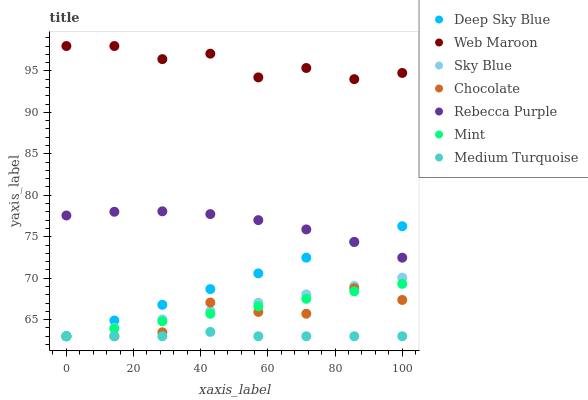Does Medium Turquoise have the minimum area under the curve?
Answer yes or no. Yes. Does Web Maroon have the maximum area under the curve?
Answer yes or no. Yes. Does Chocolate have the minimum area under the curve?
Answer yes or no. No. Does Chocolate have the maximum area under the curve?
Answer yes or no. No. Is Deep Sky Blue the smoothest?
Answer yes or no. Yes. Is Chocolate the roughest?
Answer yes or no. Yes. Is Web Maroon the smoothest?
Answer yes or no. No. Is Web Maroon the roughest?
Answer yes or no. No. Does Medium Turquoise have the lowest value?
Answer yes or no. Yes. Does Web Maroon have the lowest value?
Answer yes or no. No. Does Web Maroon have the highest value?
Answer yes or no. Yes. Does Chocolate have the highest value?
Answer yes or no. No. Is Mint less than Rebecca Purple?
Answer yes or no. Yes. Is Rebecca Purple greater than Medium Turquoise?
Answer yes or no. Yes. Does Medium Turquoise intersect Sky Blue?
Answer yes or no. Yes. Is Medium Turquoise less than Sky Blue?
Answer yes or no. No. Is Medium Turquoise greater than Sky Blue?
Answer yes or no. No. Does Mint intersect Rebecca Purple?
Answer yes or no. No. 